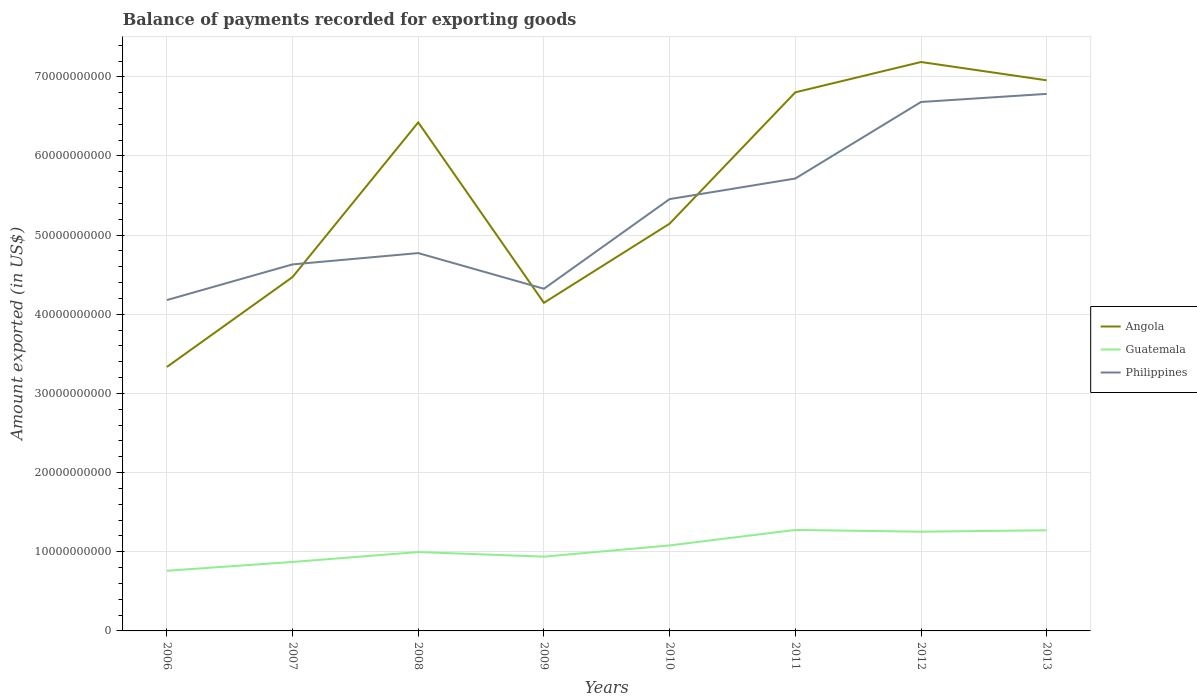How many different coloured lines are there?
Your response must be concise. 3. Is the number of lines equal to the number of legend labels?
Your answer should be compact. Yes. Across all years, what is the maximum amount exported in Angola?
Make the answer very short. 3.33e+1. In which year was the amount exported in Angola maximum?
Keep it short and to the point. 2006. What is the total amount exported in Philippines in the graph?
Your answer should be compact. -2.60e+09. What is the difference between the highest and the second highest amount exported in Guatemala?
Make the answer very short. 5.16e+09. What is the difference between the highest and the lowest amount exported in Angola?
Provide a short and direct response. 4. Is the amount exported in Angola strictly greater than the amount exported in Guatemala over the years?
Give a very brief answer. No. How many lines are there?
Provide a succinct answer. 3. Does the graph contain grids?
Provide a short and direct response. Yes. How many legend labels are there?
Make the answer very short. 3. What is the title of the graph?
Ensure brevity in your answer.  Balance of payments recorded for exporting goods. What is the label or title of the X-axis?
Make the answer very short. Years. What is the label or title of the Y-axis?
Offer a very short reply. Amount exported (in US$). What is the Amount exported (in US$) in Angola in 2006?
Your answer should be compact. 3.33e+1. What is the Amount exported (in US$) of Guatemala in 2006?
Provide a short and direct response. 7.60e+09. What is the Amount exported (in US$) in Philippines in 2006?
Keep it short and to the point. 4.18e+1. What is the Amount exported (in US$) in Angola in 2007?
Your answer should be very brief. 4.47e+1. What is the Amount exported (in US$) of Guatemala in 2007?
Provide a short and direct response. 8.71e+09. What is the Amount exported (in US$) of Philippines in 2007?
Ensure brevity in your answer.  4.63e+1. What is the Amount exported (in US$) of Angola in 2008?
Make the answer very short. 6.42e+1. What is the Amount exported (in US$) of Guatemala in 2008?
Offer a terse response. 9.97e+09. What is the Amount exported (in US$) in Philippines in 2008?
Give a very brief answer. 4.77e+1. What is the Amount exported (in US$) of Angola in 2009?
Make the answer very short. 4.15e+1. What is the Amount exported (in US$) of Guatemala in 2009?
Your answer should be very brief. 9.38e+09. What is the Amount exported (in US$) of Philippines in 2009?
Ensure brevity in your answer.  4.32e+1. What is the Amount exported (in US$) in Angola in 2010?
Offer a terse response. 5.15e+1. What is the Amount exported (in US$) of Guatemala in 2010?
Give a very brief answer. 1.08e+1. What is the Amount exported (in US$) in Philippines in 2010?
Make the answer very short. 5.46e+1. What is the Amount exported (in US$) in Angola in 2011?
Your answer should be very brief. 6.80e+1. What is the Amount exported (in US$) of Guatemala in 2011?
Give a very brief answer. 1.28e+1. What is the Amount exported (in US$) in Philippines in 2011?
Offer a terse response. 5.72e+1. What is the Amount exported (in US$) of Angola in 2012?
Ensure brevity in your answer.  7.19e+1. What is the Amount exported (in US$) in Guatemala in 2012?
Give a very brief answer. 1.25e+1. What is the Amount exported (in US$) in Philippines in 2012?
Ensure brevity in your answer.  6.68e+1. What is the Amount exported (in US$) in Angola in 2013?
Provide a succinct answer. 6.96e+1. What is the Amount exported (in US$) in Guatemala in 2013?
Your answer should be compact. 1.27e+1. What is the Amount exported (in US$) of Philippines in 2013?
Give a very brief answer. 6.78e+1. Across all years, what is the maximum Amount exported (in US$) of Angola?
Provide a short and direct response. 7.19e+1. Across all years, what is the maximum Amount exported (in US$) in Guatemala?
Make the answer very short. 1.28e+1. Across all years, what is the maximum Amount exported (in US$) of Philippines?
Offer a very short reply. 6.78e+1. Across all years, what is the minimum Amount exported (in US$) of Angola?
Give a very brief answer. 3.33e+1. Across all years, what is the minimum Amount exported (in US$) of Guatemala?
Your answer should be very brief. 7.60e+09. Across all years, what is the minimum Amount exported (in US$) in Philippines?
Your answer should be compact. 4.18e+1. What is the total Amount exported (in US$) of Angola in the graph?
Offer a terse response. 4.45e+11. What is the total Amount exported (in US$) in Guatemala in the graph?
Offer a terse response. 8.45e+1. What is the total Amount exported (in US$) of Philippines in the graph?
Keep it short and to the point. 4.25e+11. What is the difference between the Amount exported (in US$) in Angola in 2006 and that in 2007?
Give a very brief answer. -1.14e+1. What is the difference between the Amount exported (in US$) in Guatemala in 2006 and that in 2007?
Ensure brevity in your answer.  -1.11e+09. What is the difference between the Amount exported (in US$) of Philippines in 2006 and that in 2007?
Offer a terse response. -4.51e+09. What is the difference between the Amount exported (in US$) in Angola in 2006 and that in 2008?
Keep it short and to the point. -3.09e+1. What is the difference between the Amount exported (in US$) of Guatemala in 2006 and that in 2008?
Keep it short and to the point. -2.36e+09. What is the difference between the Amount exported (in US$) in Philippines in 2006 and that in 2008?
Your answer should be compact. -5.93e+09. What is the difference between the Amount exported (in US$) of Angola in 2006 and that in 2009?
Offer a very short reply. -8.10e+09. What is the difference between the Amount exported (in US$) in Guatemala in 2006 and that in 2009?
Offer a very short reply. -1.78e+09. What is the difference between the Amount exported (in US$) in Philippines in 2006 and that in 2009?
Ensure brevity in your answer.  -1.43e+09. What is the difference between the Amount exported (in US$) of Angola in 2006 and that in 2010?
Provide a short and direct response. -1.81e+1. What is the difference between the Amount exported (in US$) of Guatemala in 2006 and that in 2010?
Offer a very short reply. -3.20e+09. What is the difference between the Amount exported (in US$) of Philippines in 2006 and that in 2010?
Keep it short and to the point. -1.28e+1. What is the difference between the Amount exported (in US$) of Angola in 2006 and that in 2011?
Offer a very short reply. -3.47e+1. What is the difference between the Amount exported (in US$) of Guatemala in 2006 and that in 2011?
Your answer should be very brief. -5.16e+09. What is the difference between the Amount exported (in US$) of Philippines in 2006 and that in 2011?
Provide a short and direct response. -1.54e+1. What is the difference between the Amount exported (in US$) of Angola in 2006 and that in 2012?
Provide a succinct answer. -3.85e+1. What is the difference between the Amount exported (in US$) of Guatemala in 2006 and that in 2012?
Keep it short and to the point. -4.94e+09. What is the difference between the Amount exported (in US$) in Philippines in 2006 and that in 2012?
Ensure brevity in your answer.  -2.50e+1. What is the difference between the Amount exported (in US$) in Angola in 2006 and that in 2013?
Give a very brief answer. -3.62e+1. What is the difference between the Amount exported (in US$) of Guatemala in 2006 and that in 2013?
Provide a succinct answer. -5.11e+09. What is the difference between the Amount exported (in US$) in Philippines in 2006 and that in 2013?
Keep it short and to the point. -2.60e+1. What is the difference between the Amount exported (in US$) in Angola in 2007 and that in 2008?
Ensure brevity in your answer.  -1.95e+1. What is the difference between the Amount exported (in US$) in Guatemala in 2007 and that in 2008?
Give a very brief answer. -1.25e+09. What is the difference between the Amount exported (in US$) in Philippines in 2007 and that in 2008?
Your answer should be very brief. -1.43e+09. What is the difference between the Amount exported (in US$) of Angola in 2007 and that in 2009?
Your response must be concise. 3.26e+09. What is the difference between the Amount exported (in US$) of Guatemala in 2007 and that in 2009?
Give a very brief answer. -6.69e+08. What is the difference between the Amount exported (in US$) in Philippines in 2007 and that in 2009?
Ensure brevity in your answer.  3.08e+09. What is the difference between the Amount exported (in US$) in Angola in 2007 and that in 2010?
Provide a short and direct response. -6.74e+09. What is the difference between the Amount exported (in US$) of Guatemala in 2007 and that in 2010?
Provide a succinct answer. -2.09e+09. What is the difference between the Amount exported (in US$) of Philippines in 2007 and that in 2010?
Your answer should be compact. -8.25e+09. What is the difference between the Amount exported (in US$) in Angola in 2007 and that in 2011?
Your response must be concise. -2.33e+1. What is the difference between the Amount exported (in US$) in Guatemala in 2007 and that in 2011?
Offer a terse response. -4.04e+09. What is the difference between the Amount exported (in US$) in Philippines in 2007 and that in 2011?
Offer a terse response. -1.09e+1. What is the difference between the Amount exported (in US$) of Angola in 2007 and that in 2012?
Offer a very short reply. -2.72e+1. What is the difference between the Amount exported (in US$) in Guatemala in 2007 and that in 2012?
Your response must be concise. -3.82e+09. What is the difference between the Amount exported (in US$) in Philippines in 2007 and that in 2012?
Provide a succinct answer. -2.05e+1. What is the difference between the Amount exported (in US$) of Angola in 2007 and that in 2013?
Keep it short and to the point. -2.49e+1. What is the difference between the Amount exported (in US$) in Guatemala in 2007 and that in 2013?
Your response must be concise. -4.00e+09. What is the difference between the Amount exported (in US$) of Philippines in 2007 and that in 2013?
Give a very brief answer. -2.15e+1. What is the difference between the Amount exported (in US$) of Angola in 2008 and that in 2009?
Ensure brevity in your answer.  2.28e+1. What is the difference between the Amount exported (in US$) of Guatemala in 2008 and that in 2009?
Your response must be concise. 5.82e+08. What is the difference between the Amount exported (in US$) in Philippines in 2008 and that in 2009?
Provide a succinct answer. 4.51e+09. What is the difference between the Amount exported (in US$) of Angola in 2008 and that in 2010?
Your answer should be compact. 1.28e+1. What is the difference between the Amount exported (in US$) of Guatemala in 2008 and that in 2010?
Offer a very short reply. -8.38e+08. What is the difference between the Amount exported (in US$) in Philippines in 2008 and that in 2010?
Ensure brevity in your answer.  -6.82e+09. What is the difference between the Amount exported (in US$) of Angola in 2008 and that in 2011?
Provide a short and direct response. -3.80e+09. What is the difference between the Amount exported (in US$) of Guatemala in 2008 and that in 2011?
Make the answer very short. -2.79e+09. What is the difference between the Amount exported (in US$) in Philippines in 2008 and that in 2011?
Your answer should be very brief. -9.42e+09. What is the difference between the Amount exported (in US$) in Angola in 2008 and that in 2012?
Your answer should be compact. -7.63e+09. What is the difference between the Amount exported (in US$) of Guatemala in 2008 and that in 2012?
Offer a very short reply. -2.57e+09. What is the difference between the Amount exported (in US$) in Philippines in 2008 and that in 2012?
Your answer should be compact. -1.91e+1. What is the difference between the Amount exported (in US$) of Angola in 2008 and that in 2013?
Give a very brief answer. -5.32e+09. What is the difference between the Amount exported (in US$) of Guatemala in 2008 and that in 2013?
Make the answer very short. -2.75e+09. What is the difference between the Amount exported (in US$) in Philippines in 2008 and that in 2013?
Provide a short and direct response. -2.01e+1. What is the difference between the Amount exported (in US$) of Angola in 2009 and that in 2010?
Provide a short and direct response. -1.00e+1. What is the difference between the Amount exported (in US$) in Guatemala in 2009 and that in 2010?
Offer a very short reply. -1.42e+09. What is the difference between the Amount exported (in US$) of Philippines in 2009 and that in 2010?
Your answer should be very brief. -1.13e+1. What is the difference between the Amount exported (in US$) of Angola in 2009 and that in 2011?
Give a very brief answer. -2.66e+1. What is the difference between the Amount exported (in US$) of Guatemala in 2009 and that in 2011?
Your response must be concise. -3.37e+09. What is the difference between the Amount exported (in US$) in Philippines in 2009 and that in 2011?
Keep it short and to the point. -1.39e+1. What is the difference between the Amount exported (in US$) of Angola in 2009 and that in 2012?
Your answer should be compact. -3.04e+1. What is the difference between the Amount exported (in US$) in Guatemala in 2009 and that in 2012?
Offer a terse response. -3.15e+09. What is the difference between the Amount exported (in US$) in Philippines in 2009 and that in 2012?
Offer a very short reply. -2.36e+1. What is the difference between the Amount exported (in US$) in Angola in 2009 and that in 2013?
Make the answer very short. -2.81e+1. What is the difference between the Amount exported (in US$) of Guatemala in 2009 and that in 2013?
Make the answer very short. -3.33e+09. What is the difference between the Amount exported (in US$) of Philippines in 2009 and that in 2013?
Make the answer very short. -2.46e+1. What is the difference between the Amount exported (in US$) in Angola in 2010 and that in 2011?
Make the answer very short. -1.66e+1. What is the difference between the Amount exported (in US$) in Guatemala in 2010 and that in 2011?
Provide a short and direct response. -1.95e+09. What is the difference between the Amount exported (in US$) of Philippines in 2010 and that in 2011?
Make the answer very short. -2.60e+09. What is the difference between the Amount exported (in US$) in Angola in 2010 and that in 2012?
Provide a short and direct response. -2.04e+1. What is the difference between the Amount exported (in US$) of Guatemala in 2010 and that in 2012?
Ensure brevity in your answer.  -1.73e+09. What is the difference between the Amount exported (in US$) in Philippines in 2010 and that in 2012?
Give a very brief answer. -1.23e+1. What is the difference between the Amount exported (in US$) in Angola in 2010 and that in 2013?
Your response must be concise. -1.81e+1. What is the difference between the Amount exported (in US$) of Guatemala in 2010 and that in 2013?
Make the answer very short. -1.91e+09. What is the difference between the Amount exported (in US$) in Philippines in 2010 and that in 2013?
Provide a short and direct response. -1.33e+1. What is the difference between the Amount exported (in US$) of Angola in 2011 and that in 2012?
Ensure brevity in your answer.  -3.83e+09. What is the difference between the Amount exported (in US$) in Guatemala in 2011 and that in 2012?
Make the answer very short. 2.20e+08. What is the difference between the Amount exported (in US$) in Philippines in 2011 and that in 2012?
Your response must be concise. -9.67e+09. What is the difference between the Amount exported (in US$) in Angola in 2011 and that in 2013?
Make the answer very short. -1.52e+09. What is the difference between the Amount exported (in US$) in Guatemala in 2011 and that in 2013?
Your answer should be very brief. 4.33e+07. What is the difference between the Amount exported (in US$) of Philippines in 2011 and that in 2013?
Offer a very short reply. -1.07e+1. What is the difference between the Amount exported (in US$) of Angola in 2012 and that in 2013?
Make the answer very short. 2.31e+09. What is the difference between the Amount exported (in US$) in Guatemala in 2012 and that in 2013?
Provide a succinct answer. -1.77e+08. What is the difference between the Amount exported (in US$) of Philippines in 2012 and that in 2013?
Provide a short and direct response. -1.02e+09. What is the difference between the Amount exported (in US$) in Angola in 2006 and the Amount exported (in US$) in Guatemala in 2007?
Make the answer very short. 2.46e+1. What is the difference between the Amount exported (in US$) in Angola in 2006 and the Amount exported (in US$) in Philippines in 2007?
Your answer should be very brief. -1.30e+1. What is the difference between the Amount exported (in US$) of Guatemala in 2006 and the Amount exported (in US$) of Philippines in 2007?
Keep it short and to the point. -3.87e+1. What is the difference between the Amount exported (in US$) in Angola in 2006 and the Amount exported (in US$) in Guatemala in 2008?
Your response must be concise. 2.34e+1. What is the difference between the Amount exported (in US$) of Angola in 2006 and the Amount exported (in US$) of Philippines in 2008?
Offer a terse response. -1.44e+1. What is the difference between the Amount exported (in US$) of Guatemala in 2006 and the Amount exported (in US$) of Philippines in 2008?
Ensure brevity in your answer.  -4.01e+1. What is the difference between the Amount exported (in US$) in Angola in 2006 and the Amount exported (in US$) in Guatemala in 2009?
Make the answer very short. 2.40e+1. What is the difference between the Amount exported (in US$) of Angola in 2006 and the Amount exported (in US$) of Philippines in 2009?
Offer a terse response. -9.88e+09. What is the difference between the Amount exported (in US$) of Guatemala in 2006 and the Amount exported (in US$) of Philippines in 2009?
Your answer should be very brief. -3.56e+1. What is the difference between the Amount exported (in US$) of Angola in 2006 and the Amount exported (in US$) of Guatemala in 2010?
Provide a succinct answer. 2.25e+1. What is the difference between the Amount exported (in US$) in Angola in 2006 and the Amount exported (in US$) in Philippines in 2010?
Make the answer very short. -2.12e+1. What is the difference between the Amount exported (in US$) in Guatemala in 2006 and the Amount exported (in US$) in Philippines in 2010?
Provide a short and direct response. -4.70e+1. What is the difference between the Amount exported (in US$) of Angola in 2006 and the Amount exported (in US$) of Guatemala in 2011?
Your answer should be compact. 2.06e+1. What is the difference between the Amount exported (in US$) of Angola in 2006 and the Amount exported (in US$) of Philippines in 2011?
Offer a very short reply. -2.38e+1. What is the difference between the Amount exported (in US$) in Guatemala in 2006 and the Amount exported (in US$) in Philippines in 2011?
Make the answer very short. -4.96e+1. What is the difference between the Amount exported (in US$) in Angola in 2006 and the Amount exported (in US$) in Guatemala in 2012?
Give a very brief answer. 2.08e+1. What is the difference between the Amount exported (in US$) of Angola in 2006 and the Amount exported (in US$) of Philippines in 2012?
Provide a succinct answer. -3.35e+1. What is the difference between the Amount exported (in US$) in Guatemala in 2006 and the Amount exported (in US$) in Philippines in 2012?
Provide a succinct answer. -5.92e+1. What is the difference between the Amount exported (in US$) of Angola in 2006 and the Amount exported (in US$) of Guatemala in 2013?
Your answer should be very brief. 2.06e+1. What is the difference between the Amount exported (in US$) of Angola in 2006 and the Amount exported (in US$) of Philippines in 2013?
Offer a terse response. -3.45e+1. What is the difference between the Amount exported (in US$) in Guatemala in 2006 and the Amount exported (in US$) in Philippines in 2013?
Keep it short and to the point. -6.02e+1. What is the difference between the Amount exported (in US$) in Angola in 2007 and the Amount exported (in US$) in Guatemala in 2008?
Your response must be concise. 3.47e+1. What is the difference between the Amount exported (in US$) of Angola in 2007 and the Amount exported (in US$) of Philippines in 2008?
Offer a very short reply. -3.03e+09. What is the difference between the Amount exported (in US$) of Guatemala in 2007 and the Amount exported (in US$) of Philippines in 2008?
Give a very brief answer. -3.90e+1. What is the difference between the Amount exported (in US$) of Angola in 2007 and the Amount exported (in US$) of Guatemala in 2009?
Your answer should be compact. 3.53e+1. What is the difference between the Amount exported (in US$) in Angola in 2007 and the Amount exported (in US$) in Philippines in 2009?
Give a very brief answer. 1.48e+09. What is the difference between the Amount exported (in US$) of Guatemala in 2007 and the Amount exported (in US$) of Philippines in 2009?
Your answer should be compact. -3.45e+1. What is the difference between the Amount exported (in US$) of Angola in 2007 and the Amount exported (in US$) of Guatemala in 2010?
Offer a terse response. 3.39e+1. What is the difference between the Amount exported (in US$) in Angola in 2007 and the Amount exported (in US$) in Philippines in 2010?
Provide a succinct answer. -9.85e+09. What is the difference between the Amount exported (in US$) of Guatemala in 2007 and the Amount exported (in US$) of Philippines in 2010?
Provide a succinct answer. -4.58e+1. What is the difference between the Amount exported (in US$) in Angola in 2007 and the Amount exported (in US$) in Guatemala in 2011?
Give a very brief answer. 3.19e+1. What is the difference between the Amount exported (in US$) of Angola in 2007 and the Amount exported (in US$) of Philippines in 2011?
Provide a succinct answer. -1.24e+1. What is the difference between the Amount exported (in US$) in Guatemala in 2007 and the Amount exported (in US$) in Philippines in 2011?
Your answer should be compact. -4.84e+1. What is the difference between the Amount exported (in US$) in Angola in 2007 and the Amount exported (in US$) in Guatemala in 2012?
Your response must be concise. 3.22e+1. What is the difference between the Amount exported (in US$) of Angola in 2007 and the Amount exported (in US$) of Philippines in 2012?
Your answer should be compact. -2.21e+1. What is the difference between the Amount exported (in US$) in Guatemala in 2007 and the Amount exported (in US$) in Philippines in 2012?
Provide a succinct answer. -5.81e+1. What is the difference between the Amount exported (in US$) in Angola in 2007 and the Amount exported (in US$) in Guatemala in 2013?
Provide a succinct answer. 3.20e+1. What is the difference between the Amount exported (in US$) in Angola in 2007 and the Amount exported (in US$) in Philippines in 2013?
Offer a terse response. -2.31e+1. What is the difference between the Amount exported (in US$) in Guatemala in 2007 and the Amount exported (in US$) in Philippines in 2013?
Provide a succinct answer. -5.91e+1. What is the difference between the Amount exported (in US$) of Angola in 2008 and the Amount exported (in US$) of Guatemala in 2009?
Your response must be concise. 5.49e+1. What is the difference between the Amount exported (in US$) of Angola in 2008 and the Amount exported (in US$) of Philippines in 2009?
Your answer should be compact. 2.10e+1. What is the difference between the Amount exported (in US$) in Guatemala in 2008 and the Amount exported (in US$) in Philippines in 2009?
Ensure brevity in your answer.  -3.33e+1. What is the difference between the Amount exported (in US$) of Angola in 2008 and the Amount exported (in US$) of Guatemala in 2010?
Ensure brevity in your answer.  5.34e+1. What is the difference between the Amount exported (in US$) of Angola in 2008 and the Amount exported (in US$) of Philippines in 2010?
Give a very brief answer. 9.69e+09. What is the difference between the Amount exported (in US$) in Guatemala in 2008 and the Amount exported (in US$) in Philippines in 2010?
Provide a succinct answer. -4.46e+1. What is the difference between the Amount exported (in US$) of Angola in 2008 and the Amount exported (in US$) of Guatemala in 2011?
Offer a very short reply. 5.15e+1. What is the difference between the Amount exported (in US$) of Angola in 2008 and the Amount exported (in US$) of Philippines in 2011?
Keep it short and to the point. 7.09e+09. What is the difference between the Amount exported (in US$) in Guatemala in 2008 and the Amount exported (in US$) in Philippines in 2011?
Ensure brevity in your answer.  -4.72e+1. What is the difference between the Amount exported (in US$) in Angola in 2008 and the Amount exported (in US$) in Guatemala in 2012?
Offer a terse response. 5.17e+1. What is the difference between the Amount exported (in US$) in Angola in 2008 and the Amount exported (in US$) in Philippines in 2012?
Provide a succinct answer. -2.58e+09. What is the difference between the Amount exported (in US$) in Guatemala in 2008 and the Amount exported (in US$) in Philippines in 2012?
Provide a succinct answer. -5.69e+1. What is the difference between the Amount exported (in US$) of Angola in 2008 and the Amount exported (in US$) of Guatemala in 2013?
Your answer should be compact. 5.15e+1. What is the difference between the Amount exported (in US$) in Angola in 2008 and the Amount exported (in US$) in Philippines in 2013?
Give a very brief answer. -3.60e+09. What is the difference between the Amount exported (in US$) of Guatemala in 2008 and the Amount exported (in US$) of Philippines in 2013?
Make the answer very short. -5.79e+1. What is the difference between the Amount exported (in US$) in Angola in 2009 and the Amount exported (in US$) in Guatemala in 2010?
Offer a terse response. 3.06e+1. What is the difference between the Amount exported (in US$) in Angola in 2009 and the Amount exported (in US$) in Philippines in 2010?
Offer a terse response. -1.31e+1. What is the difference between the Amount exported (in US$) of Guatemala in 2009 and the Amount exported (in US$) of Philippines in 2010?
Provide a short and direct response. -4.52e+1. What is the difference between the Amount exported (in US$) in Angola in 2009 and the Amount exported (in US$) in Guatemala in 2011?
Make the answer very short. 2.87e+1. What is the difference between the Amount exported (in US$) of Angola in 2009 and the Amount exported (in US$) of Philippines in 2011?
Offer a very short reply. -1.57e+1. What is the difference between the Amount exported (in US$) of Guatemala in 2009 and the Amount exported (in US$) of Philippines in 2011?
Your response must be concise. -4.78e+1. What is the difference between the Amount exported (in US$) of Angola in 2009 and the Amount exported (in US$) of Guatemala in 2012?
Ensure brevity in your answer.  2.89e+1. What is the difference between the Amount exported (in US$) of Angola in 2009 and the Amount exported (in US$) of Philippines in 2012?
Offer a terse response. -2.54e+1. What is the difference between the Amount exported (in US$) of Guatemala in 2009 and the Amount exported (in US$) of Philippines in 2012?
Your answer should be compact. -5.74e+1. What is the difference between the Amount exported (in US$) of Angola in 2009 and the Amount exported (in US$) of Guatemala in 2013?
Make the answer very short. 2.87e+1. What is the difference between the Amount exported (in US$) in Angola in 2009 and the Amount exported (in US$) in Philippines in 2013?
Give a very brief answer. -2.64e+1. What is the difference between the Amount exported (in US$) of Guatemala in 2009 and the Amount exported (in US$) of Philippines in 2013?
Your response must be concise. -5.85e+1. What is the difference between the Amount exported (in US$) in Angola in 2010 and the Amount exported (in US$) in Guatemala in 2011?
Make the answer very short. 3.87e+1. What is the difference between the Amount exported (in US$) in Angola in 2010 and the Amount exported (in US$) in Philippines in 2011?
Provide a succinct answer. -5.70e+09. What is the difference between the Amount exported (in US$) of Guatemala in 2010 and the Amount exported (in US$) of Philippines in 2011?
Your answer should be compact. -4.64e+1. What is the difference between the Amount exported (in US$) of Angola in 2010 and the Amount exported (in US$) of Guatemala in 2012?
Your response must be concise. 3.89e+1. What is the difference between the Amount exported (in US$) of Angola in 2010 and the Amount exported (in US$) of Philippines in 2012?
Your response must be concise. -1.54e+1. What is the difference between the Amount exported (in US$) of Guatemala in 2010 and the Amount exported (in US$) of Philippines in 2012?
Provide a short and direct response. -5.60e+1. What is the difference between the Amount exported (in US$) of Angola in 2010 and the Amount exported (in US$) of Guatemala in 2013?
Provide a short and direct response. 3.87e+1. What is the difference between the Amount exported (in US$) in Angola in 2010 and the Amount exported (in US$) in Philippines in 2013?
Keep it short and to the point. -1.64e+1. What is the difference between the Amount exported (in US$) in Guatemala in 2010 and the Amount exported (in US$) in Philippines in 2013?
Ensure brevity in your answer.  -5.70e+1. What is the difference between the Amount exported (in US$) in Angola in 2011 and the Amount exported (in US$) in Guatemala in 2012?
Offer a terse response. 5.55e+1. What is the difference between the Amount exported (in US$) of Angola in 2011 and the Amount exported (in US$) of Philippines in 2012?
Give a very brief answer. 1.22e+09. What is the difference between the Amount exported (in US$) in Guatemala in 2011 and the Amount exported (in US$) in Philippines in 2012?
Provide a succinct answer. -5.41e+1. What is the difference between the Amount exported (in US$) in Angola in 2011 and the Amount exported (in US$) in Guatemala in 2013?
Your answer should be very brief. 5.53e+1. What is the difference between the Amount exported (in US$) of Angola in 2011 and the Amount exported (in US$) of Philippines in 2013?
Your answer should be very brief. 1.95e+08. What is the difference between the Amount exported (in US$) of Guatemala in 2011 and the Amount exported (in US$) of Philippines in 2013?
Keep it short and to the point. -5.51e+1. What is the difference between the Amount exported (in US$) of Angola in 2012 and the Amount exported (in US$) of Guatemala in 2013?
Make the answer very short. 5.92e+1. What is the difference between the Amount exported (in US$) in Angola in 2012 and the Amount exported (in US$) in Philippines in 2013?
Provide a short and direct response. 4.03e+09. What is the difference between the Amount exported (in US$) of Guatemala in 2012 and the Amount exported (in US$) of Philippines in 2013?
Give a very brief answer. -5.53e+1. What is the average Amount exported (in US$) in Angola per year?
Keep it short and to the point. 5.56e+1. What is the average Amount exported (in US$) of Guatemala per year?
Give a very brief answer. 1.06e+1. What is the average Amount exported (in US$) in Philippines per year?
Your answer should be very brief. 5.32e+1. In the year 2006, what is the difference between the Amount exported (in US$) of Angola and Amount exported (in US$) of Guatemala?
Provide a short and direct response. 2.57e+1. In the year 2006, what is the difference between the Amount exported (in US$) of Angola and Amount exported (in US$) of Philippines?
Make the answer very short. -8.45e+09. In the year 2006, what is the difference between the Amount exported (in US$) of Guatemala and Amount exported (in US$) of Philippines?
Keep it short and to the point. -3.42e+1. In the year 2007, what is the difference between the Amount exported (in US$) of Angola and Amount exported (in US$) of Guatemala?
Offer a very short reply. 3.60e+1. In the year 2007, what is the difference between the Amount exported (in US$) in Angola and Amount exported (in US$) in Philippines?
Keep it short and to the point. -1.60e+09. In the year 2007, what is the difference between the Amount exported (in US$) of Guatemala and Amount exported (in US$) of Philippines?
Offer a terse response. -3.76e+1. In the year 2008, what is the difference between the Amount exported (in US$) of Angola and Amount exported (in US$) of Guatemala?
Provide a succinct answer. 5.43e+1. In the year 2008, what is the difference between the Amount exported (in US$) of Angola and Amount exported (in US$) of Philippines?
Offer a terse response. 1.65e+1. In the year 2008, what is the difference between the Amount exported (in US$) of Guatemala and Amount exported (in US$) of Philippines?
Ensure brevity in your answer.  -3.78e+1. In the year 2009, what is the difference between the Amount exported (in US$) of Angola and Amount exported (in US$) of Guatemala?
Offer a very short reply. 3.21e+1. In the year 2009, what is the difference between the Amount exported (in US$) of Angola and Amount exported (in US$) of Philippines?
Give a very brief answer. -1.78e+09. In the year 2009, what is the difference between the Amount exported (in US$) in Guatemala and Amount exported (in US$) in Philippines?
Your answer should be very brief. -3.38e+1. In the year 2010, what is the difference between the Amount exported (in US$) in Angola and Amount exported (in US$) in Guatemala?
Keep it short and to the point. 4.06e+1. In the year 2010, what is the difference between the Amount exported (in US$) in Angola and Amount exported (in US$) in Philippines?
Provide a succinct answer. -3.10e+09. In the year 2010, what is the difference between the Amount exported (in US$) of Guatemala and Amount exported (in US$) of Philippines?
Your answer should be very brief. -4.38e+1. In the year 2011, what is the difference between the Amount exported (in US$) of Angola and Amount exported (in US$) of Guatemala?
Offer a terse response. 5.53e+1. In the year 2011, what is the difference between the Amount exported (in US$) in Angola and Amount exported (in US$) in Philippines?
Your answer should be very brief. 1.09e+1. In the year 2011, what is the difference between the Amount exported (in US$) of Guatemala and Amount exported (in US$) of Philippines?
Ensure brevity in your answer.  -4.44e+1. In the year 2012, what is the difference between the Amount exported (in US$) in Angola and Amount exported (in US$) in Guatemala?
Your answer should be very brief. 5.93e+1. In the year 2012, what is the difference between the Amount exported (in US$) in Angola and Amount exported (in US$) in Philippines?
Your answer should be compact. 5.05e+09. In the year 2012, what is the difference between the Amount exported (in US$) of Guatemala and Amount exported (in US$) of Philippines?
Make the answer very short. -5.43e+1. In the year 2013, what is the difference between the Amount exported (in US$) in Angola and Amount exported (in US$) in Guatemala?
Provide a succinct answer. 5.68e+1. In the year 2013, what is the difference between the Amount exported (in US$) of Angola and Amount exported (in US$) of Philippines?
Your answer should be compact. 1.71e+09. In the year 2013, what is the difference between the Amount exported (in US$) in Guatemala and Amount exported (in US$) in Philippines?
Ensure brevity in your answer.  -5.51e+1. What is the ratio of the Amount exported (in US$) in Angola in 2006 to that in 2007?
Your response must be concise. 0.75. What is the ratio of the Amount exported (in US$) in Guatemala in 2006 to that in 2007?
Your response must be concise. 0.87. What is the ratio of the Amount exported (in US$) of Philippines in 2006 to that in 2007?
Provide a short and direct response. 0.9. What is the ratio of the Amount exported (in US$) in Angola in 2006 to that in 2008?
Offer a very short reply. 0.52. What is the ratio of the Amount exported (in US$) in Guatemala in 2006 to that in 2008?
Your answer should be compact. 0.76. What is the ratio of the Amount exported (in US$) of Philippines in 2006 to that in 2008?
Your answer should be very brief. 0.88. What is the ratio of the Amount exported (in US$) of Angola in 2006 to that in 2009?
Keep it short and to the point. 0.8. What is the ratio of the Amount exported (in US$) in Guatemala in 2006 to that in 2009?
Keep it short and to the point. 0.81. What is the ratio of the Amount exported (in US$) of Philippines in 2006 to that in 2009?
Your answer should be very brief. 0.97. What is the ratio of the Amount exported (in US$) of Angola in 2006 to that in 2010?
Ensure brevity in your answer.  0.65. What is the ratio of the Amount exported (in US$) of Guatemala in 2006 to that in 2010?
Offer a terse response. 0.7. What is the ratio of the Amount exported (in US$) of Philippines in 2006 to that in 2010?
Give a very brief answer. 0.77. What is the ratio of the Amount exported (in US$) in Angola in 2006 to that in 2011?
Give a very brief answer. 0.49. What is the ratio of the Amount exported (in US$) of Guatemala in 2006 to that in 2011?
Your answer should be very brief. 0.6. What is the ratio of the Amount exported (in US$) in Philippines in 2006 to that in 2011?
Provide a succinct answer. 0.73. What is the ratio of the Amount exported (in US$) of Angola in 2006 to that in 2012?
Your answer should be very brief. 0.46. What is the ratio of the Amount exported (in US$) of Guatemala in 2006 to that in 2012?
Your answer should be very brief. 0.61. What is the ratio of the Amount exported (in US$) in Philippines in 2006 to that in 2012?
Provide a succinct answer. 0.63. What is the ratio of the Amount exported (in US$) of Angola in 2006 to that in 2013?
Give a very brief answer. 0.48. What is the ratio of the Amount exported (in US$) in Guatemala in 2006 to that in 2013?
Provide a succinct answer. 0.6. What is the ratio of the Amount exported (in US$) of Philippines in 2006 to that in 2013?
Provide a short and direct response. 0.62. What is the ratio of the Amount exported (in US$) of Angola in 2007 to that in 2008?
Make the answer very short. 0.7. What is the ratio of the Amount exported (in US$) of Guatemala in 2007 to that in 2008?
Provide a succinct answer. 0.87. What is the ratio of the Amount exported (in US$) of Philippines in 2007 to that in 2008?
Keep it short and to the point. 0.97. What is the ratio of the Amount exported (in US$) in Angola in 2007 to that in 2009?
Keep it short and to the point. 1.08. What is the ratio of the Amount exported (in US$) of Guatemala in 2007 to that in 2009?
Ensure brevity in your answer.  0.93. What is the ratio of the Amount exported (in US$) in Philippines in 2007 to that in 2009?
Offer a terse response. 1.07. What is the ratio of the Amount exported (in US$) in Angola in 2007 to that in 2010?
Give a very brief answer. 0.87. What is the ratio of the Amount exported (in US$) in Guatemala in 2007 to that in 2010?
Make the answer very short. 0.81. What is the ratio of the Amount exported (in US$) of Philippines in 2007 to that in 2010?
Make the answer very short. 0.85. What is the ratio of the Amount exported (in US$) in Angola in 2007 to that in 2011?
Provide a succinct answer. 0.66. What is the ratio of the Amount exported (in US$) of Guatemala in 2007 to that in 2011?
Your answer should be very brief. 0.68. What is the ratio of the Amount exported (in US$) in Philippines in 2007 to that in 2011?
Ensure brevity in your answer.  0.81. What is the ratio of the Amount exported (in US$) in Angola in 2007 to that in 2012?
Give a very brief answer. 0.62. What is the ratio of the Amount exported (in US$) of Guatemala in 2007 to that in 2012?
Provide a short and direct response. 0.7. What is the ratio of the Amount exported (in US$) of Philippines in 2007 to that in 2012?
Give a very brief answer. 0.69. What is the ratio of the Amount exported (in US$) of Angola in 2007 to that in 2013?
Your answer should be compact. 0.64. What is the ratio of the Amount exported (in US$) of Guatemala in 2007 to that in 2013?
Keep it short and to the point. 0.69. What is the ratio of the Amount exported (in US$) of Philippines in 2007 to that in 2013?
Offer a very short reply. 0.68. What is the ratio of the Amount exported (in US$) in Angola in 2008 to that in 2009?
Give a very brief answer. 1.55. What is the ratio of the Amount exported (in US$) in Guatemala in 2008 to that in 2009?
Your answer should be very brief. 1.06. What is the ratio of the Amount exported (in US$) of Philippines in 2008 to that in 2009?
Your response must be concise. 1.1. What is the ratio of the Amount exported (in US$) of Angola in 2008 to that in 2010?
Ensure brevity in your answer.  1.25. What is the ratio of the Amount exported (in US$) in Guatemala in 2008 to that in 2010?
Offer a terse response. 0.92. What is the ratio of the Amount exported (in US$) in Angola in 2008 to that in 2011?
Offer a terse response. 0.94. What is the ratio of the Amount exported (in US$) of Guatemala in 2008 to that in 2011?
Keep it short and to the point. 0.78. What is the ratio of the Amount exported (in US$) of Philippines in 2008 to that in 2011?
Your answer should be compact. 0.84. What is the ratio of the Amount exported (in US$) of Angola in 2008 to that in 2012?
Your answer should be compact. 0.89. What is the ratio of the Amount exported (in US$) in Guatemala in 2008 to that in 2012?
Your response must be concise. 0.79. What is the ratio of the Amount exported (in US$) in Angola in 2008 to that in 2013?
Provide a succinct answer. 0.92. What is the ratio of the Amount exported (in US$) in Guatemala in 2008 to that in 2013?
Give a very brief answer. 0.78. What is the ratio of the Amount exported (in US$) in Philippines in 2008 to that in 2013?
Provide a succinct answer. 0.7. What is the ratio of the Amount exported (in US$) in Angola in 2009 to that in 2010?
Offer a terse response. 0.81. What is the ratio of the Amount exported (in US$) in Guatemala in 2009 to that in 2010?
Your answer should be very brief. 0.87. What is the ratio of the Amount exported (in US$) in Philippines in 2009 to that in 2010?
Offer a very short reply. 0.79. What is the ratio of the Amount exported (in US$) in Angola in 2009 to that in 2011?
Provide a succinct answer. 0.61. What is the ratio of the Amount exported (in US$) in Guatemala in 2009 to that in 2011?
Your answer should be compact. 0.74. What is the ratio of the Amount exported (in US$) in Philippines in 2009 to that in 2011?
Your response must be concise. 0.76. What is the ratio of the Amount exported (in US$) in Angola in 2009 to that in 2012?
Give a very brief answer. 0.58. What is the ratio of the Amount exported (in US$) in Guatemala in 2009 to that in 2012?
Your answer should be compact. 0.75. What is the ratio of the Amount exported (in US$) in Philippines in 2009 to that in 2012?
Your answer should be very brief. 0.65. What is the ratio of the Amount exported (in US$) in Angola in 2009 to that in 2013?
Ensure brevity in your answer.  0.6. What is the ratio of the Amount exported (in US$) in Guatemala in 2009 to that in 2013?
Provide a short and direct response. 0.74. What is the ratio of the Amount exported (in US$) of Philippines in 2009 to that in 2013?
Your answer should be very brief. 0.64. What is the ratio of the Amount exported (in US$) in Angola in 2010 to that in 2011?
Give a very brief answer. 0.76. What is the ratio of the Amount exported (in US$) in Guatemala in 2010 to that in 2011?
Keep it short and to the point. 0.85. What is the ratio of the Amount exported (in US$) of Philippines in 2010 to that in 2011?
Ensure brevity in your answer.  0.95. What is the ratio of the Amount exported (in US$) in Angola in 2010 to that in 2012?
Keep it short and to the point. 0.72. What is the ratio of the Amount exported (in US$) in Guatemala in 2010 to that in 2012?
Your answer should be compact. 0.86. What is the ratio of the Amount exported (in US$) in Philippines in 2010 to that in 2012?
Make the answer very short. 0.82. What is the ratio of the Amount exported (in US$) in Angola in 2010 to that in 2013?
Keep it short and to the point. 0.74. What is the ratio of the Amount exported (in US$) in Guatemala in 2010 to that in 2013?
Ensure brevity in your answer.  0.85. What is the ratio of the Amount exported (in US$) in Philippines in 2010 to that in 2013?
Offer a terse response. 0.8. What is the ratio of the Amount exported (in US$) of Angola in 2011 to that in 2012?
Provide a succinct answer. 0.95. What is the ratio of the Amount exported (in US$) in Guatemala in 2011 to that in 2012?
Ensure brevity in your answer.  1.02. What is the ratio of the Amount exported (in US$) of Philippines in 2011 to that in 2012?
Make the answer very short. 0.86. What is the ratio of the Amount exported (in US$) of Angola in 2011 to that in 2013?
Your response must be concise. 0.98. What is the ratio of the Amount exported (in US$) in Guatemala in 2011 to that in 2013?
Provide a succinct answer. 1. What is the ratio of the Amount exported (in US$) of Philippines in 2011 to that in 2013?
Ensure brevity in your answer.  0.84. What is the ratio of the Amount exported (in US$) in Angola in 2012 to that in 2013?
Offer a very short reply. 1.03. What is the ratio of the Amount exported (in US$) in Guatemala in 2012 to that in 2013?
Offer a very short reply. 0.99. What is the ratio of the Amount exported (in US$) in Philippines in 2012 to that in 2013?
Provide a succinct answer. 0.98. What is the difference between the highest and the second highest Amount exported (in US$) in Angola?
Ensure brevity in your answer.  2.31e+09. What is the difference between the highest and the second highest Amount exported (in US$) in Guatemala?
Give a very brief answer. 4.33e+07. What is the difference between the highest and the second highest Amount exported (in US$) of Philippines?
Make the answer very short. 1.02e+09. What is the difference between the highest and the lowest Amount exported (in US$) of Angola?
Make the answer very short. 3.85e+1. What is the difference between the highest and the lowest Amount exported (in US$) of Guatemala?
Keep it short and to the point. 5.16e+09. What is the difference between the highest and the lowest Amount exported (in US$) in Philippines?
Offer a very short reply. 2.60e+1. 